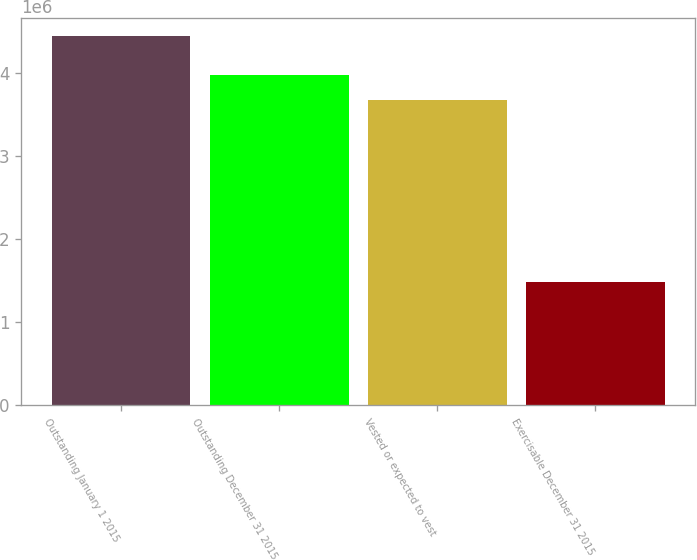Convert chart. <chart><loc_0><loc_0><loc_500><loc_500><bar_chart><fcel>Outstanding January 1 2015<fcel>Outstanding December 31 2015<fcel>Vested or expected to vest<fcel>Exercisable December 31 2015<nl><fcel>4.44236e+06<fcel>3.9776e+06<fcel>3.68137e+06<fcel>1.48003e+06<nl></chart> 